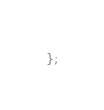<code> <loc_0><loc_0><loc_500><loc_500><_TypeScript_>};
</code> 